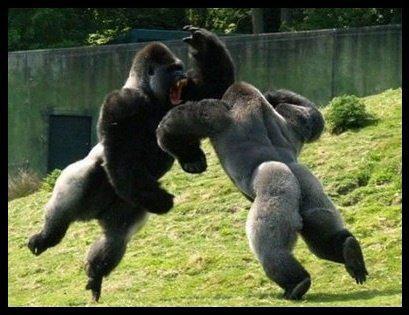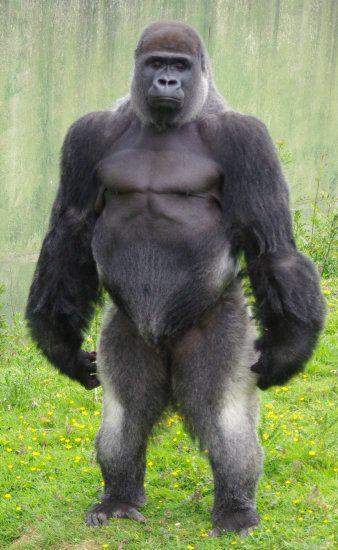The first image is the image on the left, the second image is the image on the right. For the images displayed, is the sentence "There is at least one monkey standing on all four paws." factually correct? Answer yes or no. No. The first image is the image on the left, the second image is the image on the right. Evaluate the accuracy of this statement regarding the images: "The gorilla in the image on the right is standing completely upright.". Is it true? Answer yes or no. Yes. 